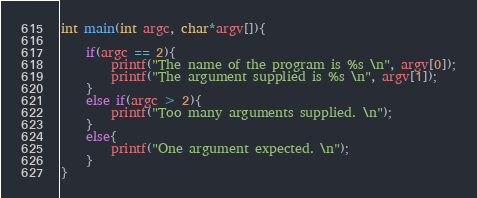<code> <loc_0><loc_0><loc_500><loc_500><_C_>
int main(int argc, char*argv[]){
	
	if(argc == 2){
		printf("The name of the program is %s \n", argv[0]);
		printf("The argument supplied is %s \n", argv[1]);
	}
	else if(argc > 2){
		printf("Too many arguments supplied. \n");
	}
	else{
		printf("One argument expected. \n");
	}
}
</code> 